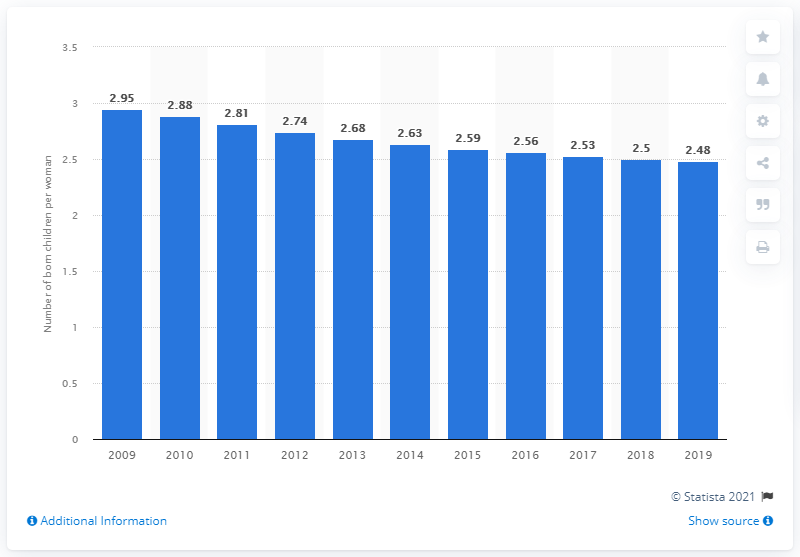Draw attention to some important aspects in this diagram. According to data from 2019, the fertility rate in Cambodia was 2.48. 